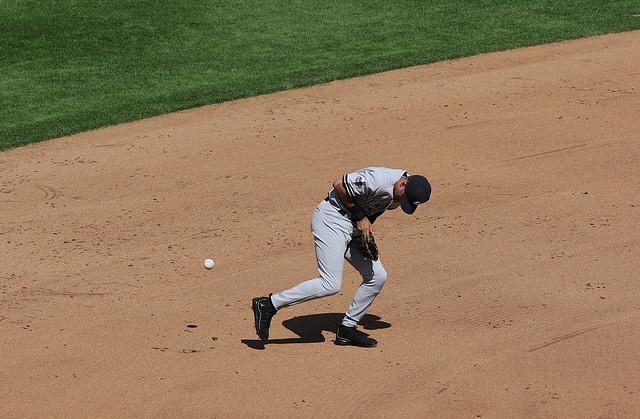How many people are present?
Give a very brief answer. 1. 